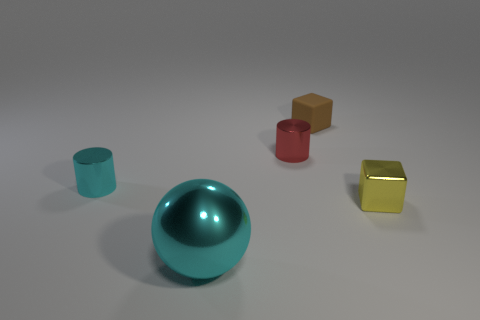What could be the purpose of arranging these objects in this manner? The arrangement of the objects could be for a visual study of shapes, colors, and reflections. It provides an opportunity to observe how light interacts with objects of varying colors and surfaces, and how these factors affect our perception of their forms. Could the arrangement represent any concept or is it just random? While it could be a random aesthetic arrangement, it's also possible that the setup represents concepts such as balance, contrast or even minimalist representation. Artists or designers may set up scenes like this to convey simplicity, focus on the interplay between different geometries, or to showcase the purity of color and form. 